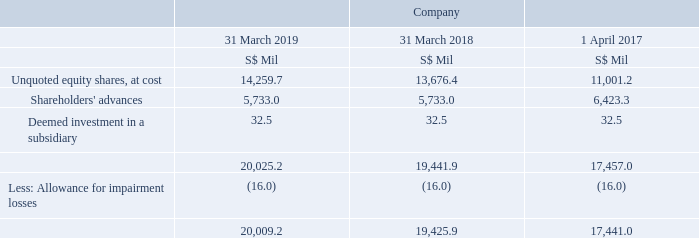21. Subsidiaries
The advances given to subsidiaries were interest-free and unsecured with settlement neither planned nor likely to occur in the foreseeable future.
The deemed investment in a subsidiary, Singtel Group Treasury Pte. Ltd. (“SGT”), arose from financial guarantees provided by the Company for loans drawn down by SGT prior to 1 April 2010.
The significant subsidiaries of the Group are set out in Note 44.1 to Note 44.3.
What is the topic of note 21? Subsidiaries. Which subsidiary is there a deemed investment in? Singtel group treasury pte. ltd. (“sgt”). What are the terms of the shareholders' advances? Interest-free and unsecured with settlement neither planned nor likely to occur in the foreseeable future. What is the average balance of the total across the 3 years?
Answer scale should be: million. (20,009.2 + 19,425.9 + 17,441.0) / 3
Answer: 18958.7. What is the average allowance for impairment losses across the 3 years?
Answer scale should be: million. (16.0 + 16.0 + 16.0 )/ 3
Answer: 16. How many factors are involved in calculating the balance for subsidiaries? Unquoted equity shares##Shareholders' advances##Deemed investment in a subsidiary##Allowance for impairment losses
Answer: 4. 